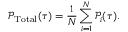Convert formula to latex. <formula><loc_0><loc_0><loc_500><loc_500>\mathcal { P } _ { T o t a l } ( \tau ) = \frac { 1 } { N } \sum _ { i = 1 } ^ { N } \mathcal { P } _ { i } ( \tau ) .</formula> 